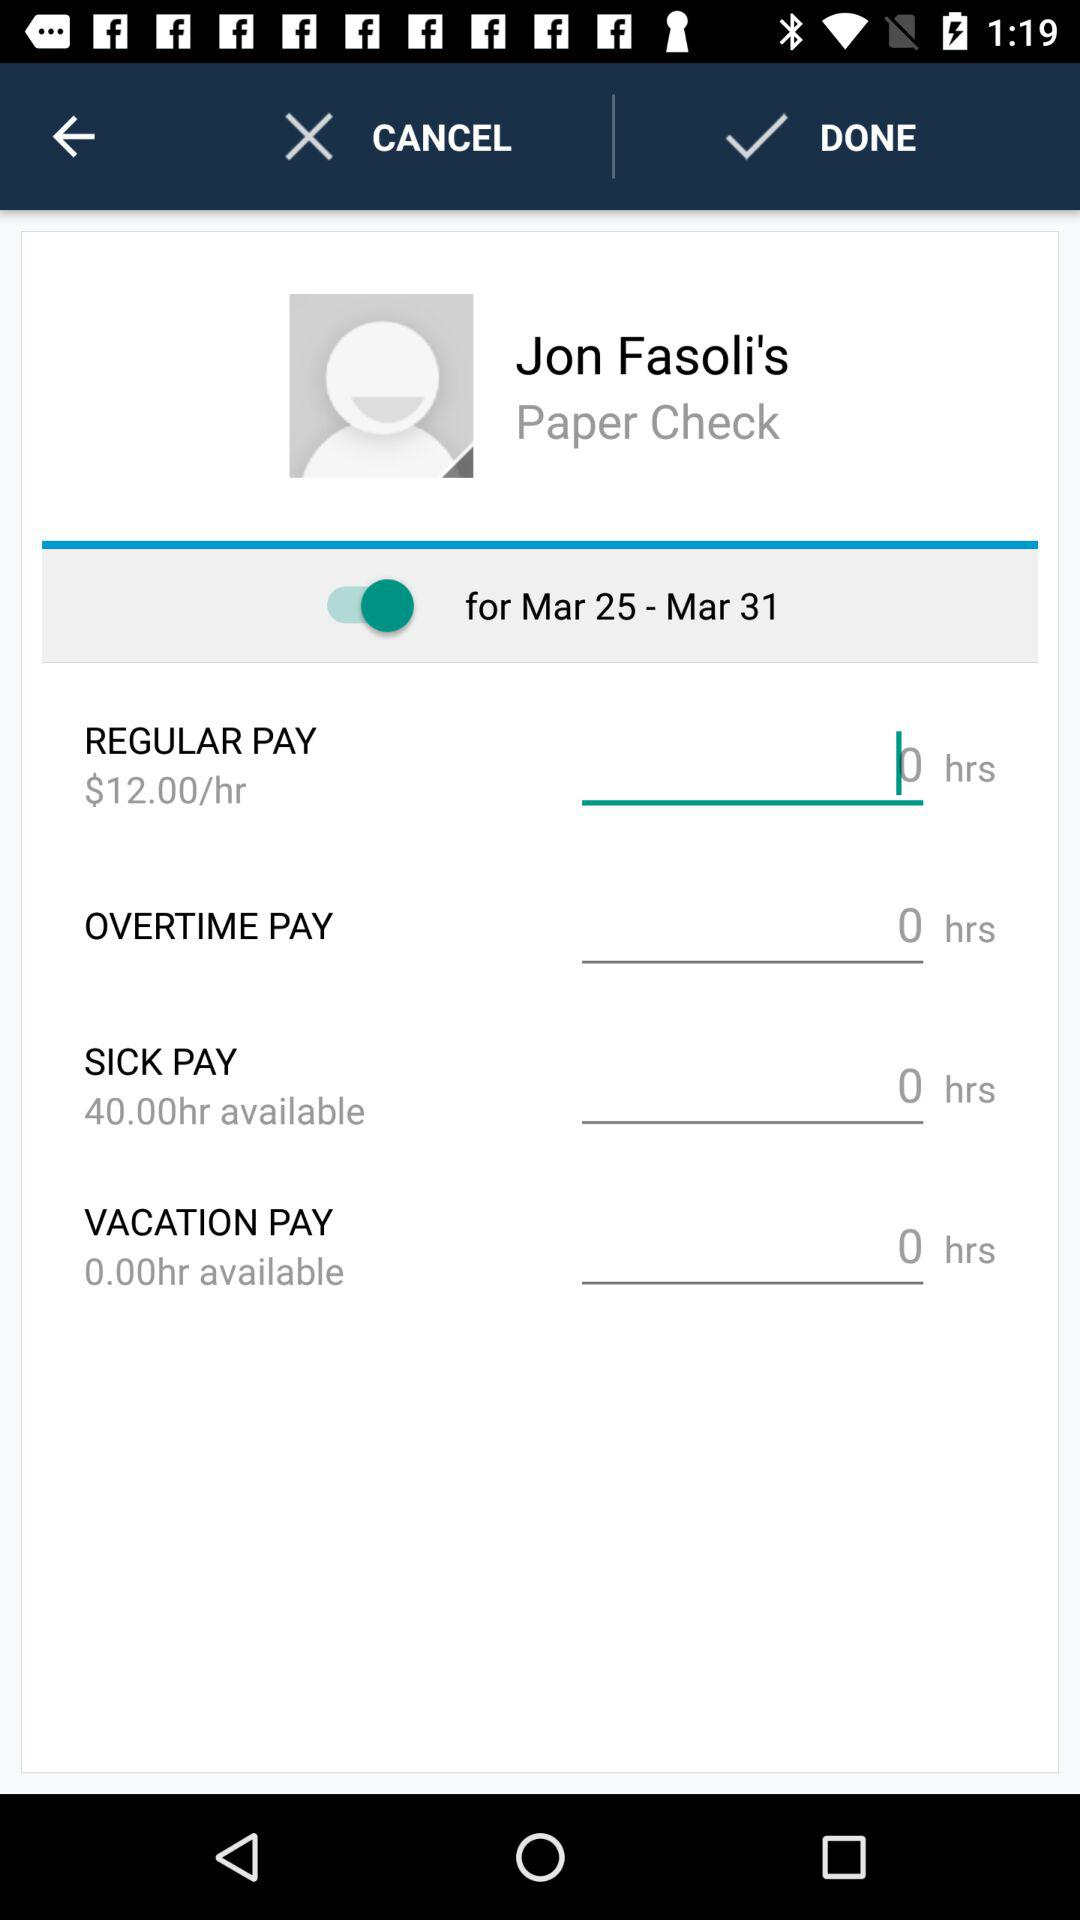How much will they pay for an hour on a regular day? On a regular day, they will pay $12 for an hour. 